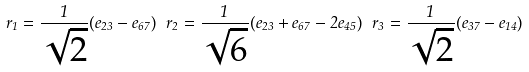Convert formula to latex. <formula><loc_0><loc_0><loc_500><loc_500>\ r _ { 1 } = \frac { 1 } { \sqrt { 2 } } ( e _ { 2 3 } - e _ { 6 7 } ) ^ { \ } r _ { 2 } = \frac { 1 } { \sqrt { 6 } } ( e _ { 2 3 } + e _ { 6 7 } - 2 e _ { 4 5 } ) ^ { \ } r _ { 3 } = \frac { 1 } { \sqrt { 2 } } ( e _ { 3 7 } - e _ { 1 4 } )</formula> 